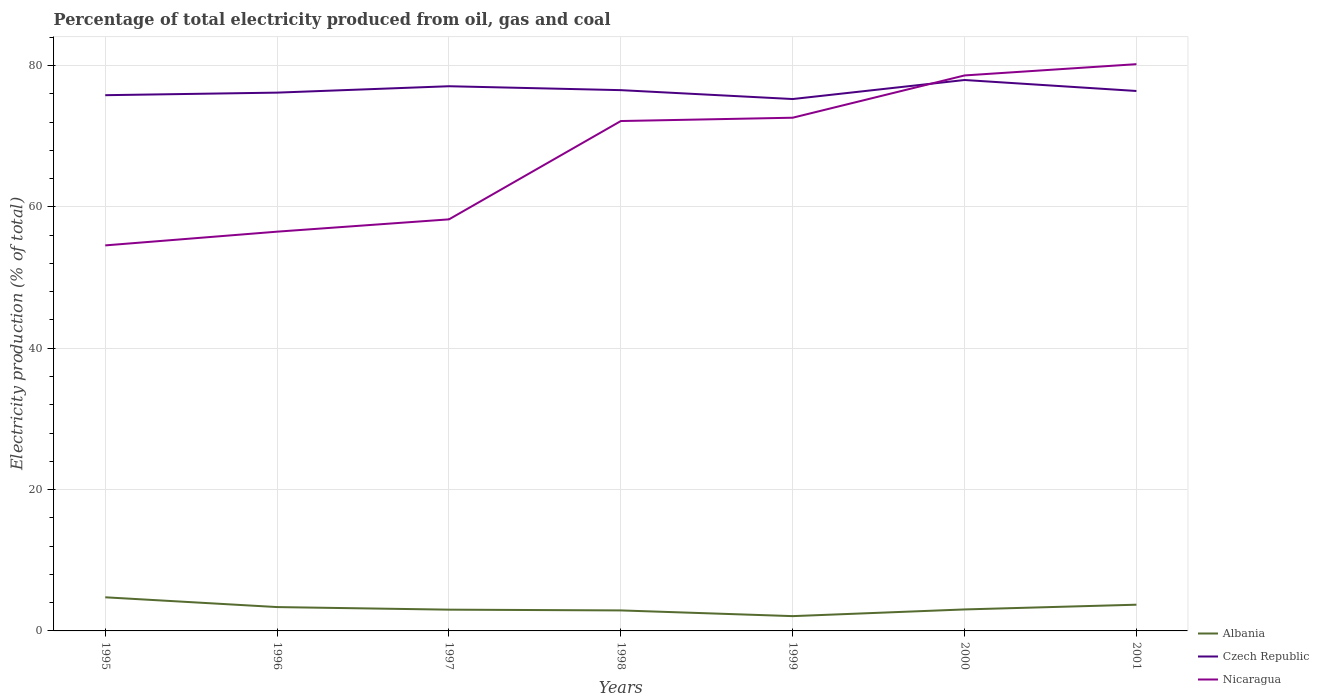Across all years, what is the maximum electricity production in in Nicaragua?
Your response must be concise. 54.56. What is the total electricity production in in Czech Republic in the graph?
Keep it short and to the point. 1.26. What is the difference between the highest and the second highest electricity production in in Nicaragua?
Provide a succinct answer. 25.64. What is the difference between the highest and the lowest electricity production in in Nicaragua?
Give a very brief answer. 4. How many lines are there?
Offer a very short reply. 3. How many years are there in the graph?
Your answer should be compact. 7. Are the values on the major ticks of Y-axis written in scientific E-notation?
Make the answer very short. No. Does the graph contain any zero values?
Make the answer very short. No. Does the graph contain grids?
Provide a succinct answer. Yes. What is the title of the graph?
Provide a succinct answer. Percentage of total electricity produced from oil, gas and coal. Does "Trinidad and Tobago" appear as one of the legend labels in the graph?
Your response must be concise. No. What is the label or title of the Y-axis?
Keep it short and to the point. Electricity production (% of total). What is the Electricity production (% of total) of Albania in 1995?
Your response must be concise. 4.76. What is the Electricity production (% of total) of Czech Republic in 1995?
Offer a very short reply. 75.81. What is the Electricity production (% of total) in Nicaragua in 1995?
Ensure brevity in your answer.  54.56. What is the Electricity production (% of total) of Albania in 1996?
Keep it short and to the point. 3.37. What is the Electricity production (% of total) in Czech Republic in 1996?
Provide a short and direct response. 76.17. What is the Electricity production (% of total) in Nicaragua in 1996?
Your answer should be compact. 56.5. What is the Electricity production (% of total) of Albania in 1997?
Offer a terse response. 3.01. What is the Electricity production (% of total) of Czech Republic in 1997?
Your response must be concise. 77.08. What is the Electricity production (% of total) of Nicaragua in 1997?
Provide a succinct answer. 58.24. What is the Electricity production (% of total) in Albania in 1998?
Give a very brief answer. 2.9. What is the Electricity production (% of total) in Czech Republic in 1998?
Provide a short and direct response. 76.52. What is the Electricity production (% of total) in Nicaragua in 1998?
Your answer should be very brief. 72.15. What is the Electricity production (% of total) in Albania in 1999?
Provide a short and direct response. 2.09. What is the Electricity production (% of total) in Czech Republic in 1999?
Ensure brevity in your answer.  75.26. What is the Electricity production (% of total) in Nicaragua in 1999?
Make the answer very short. 72.62. What is the Electricity production (% of total) in Albania in 2000?
Your answer should be very brief. 3.04. What is the Electricity production (% of total) of Czech Republic in 2000?
Your answer should be compact. 77.96. What is the Electricity production (% of total) in Nicaragua in 2000?
Your answer should be very brief. 78.6. What is the Electricity production (% of total) of Albania in 2001?
Offer a very short reply. 3.71. What is the Electricity production (% of total) of Czech Republic in 2001?
Your answer should be compact. 76.4. What is the Electricity production (% of total) of Nicaragua in 2001?
Your answer should be compact. 80.2. Across all years, what is the maximum Electricity production (% of total) of Albania?
Make the answer very short. 4.76. Across all years, what is the maximum Electricity production (% of total) of Czech Republic?
Offer a terse response. 77.96. Across all years, what is the maximum Electricity production (% of total) of Nicaragua?
Your response must be concise. 80.2. Across all years, what is the minimum Electricity production (% of total) of Albania?
Offer a very short reply. 2.09. Across all years, what is the minimum Electricity production (% of total) in Czech Republic?
Make the answer very short. 75.26. Across all years, what is the minimum Electricity production (% of total) in Nicaragua?
Your answer should be very brief. 54.56. What is the total Electricity production (% of total) of Albania in the graph?
Your answer should be very brief. 22.89. What is the total Electricity production (% of total) of Czech Republic in the graph?
Offer a very short reply. 535.21. What is the total Electricity production (% of total) of Nicaragua in the graph?
Provide a short and direct response. 472.87. What is the difference between the Electricity production (% of total) in Albania in 1995 and that in 1996?
Provide a short and direct response. 1.38. What is the difference between the Electricity production (% of total) of Czech Republic in 1995 and that in 1996?
Give a very brief answer. -0.36. What is the difference between the Electricity production (% of total) in Nicaragua in 1995 and that in 1996?
Make the answer very short. -1.94. What is the difference between the Electricity production (% of total) in Albania in 1995 and that in 1997?
Make the answer very short. 1.75. What is the difference between the Electricity production (% of total) of Czech Republic in 1995 and that in 1997?
Provide a succinct answer. -1.27. What is the difference between the Electricity production (% of total) of Nicaragua in 1995 and that in 1997?
Make the answer very short. -3.68. What is the difference between the Electricity production (% of total) in Albania in 1995 and that in 1998?
Offer a terse response. 1.86. What is the difference between the Electricity production (% of total) of Czech Republic in 1995 and that in 1998?
Keep it short and to the point. -0.71. What is the difference between the Electricity production (% of total) in Nicaragua in 1995 and that in 1998?
Give a very brief answer. -17.6. What is the difference between the Electricity production (% of total) in Albania in 1995 and that in 1999?
Your answer should be very brief. 2.66. What is the difference between the Electricity production (% of total) in Czech Republic in 1995 and that in 1999?
Keep it short and to the point. 0.55. What is the difference between the Electricity production (% of total) in Nicaragua in 1995 and that in 1999?
Keep it short and to the point. -18.07. What is the difference between the Electricity production (% of total) of Albania in 1995 and that in 2000?
Your response must be concise. 1.72. What is the difference between the Electricity production (% of total) of Czech Republic in 1995 and that in 2000?
Give a very brief answer. -2.15. What is the difference between the Electricity production (% of total) in Nicaragua in 1995 and that in 2000?
Give a very brief answer. -24.05. What is the difference between the Electricity production (% of total) of Albania in 1995 and that in 2001?
Provide a succinct answer. 1.05. What is the difference between the Electricity production (% of total) in Czech Republic in 1995 and that in 2001?
Make the answer very short. -0.59. What is the difference between the Electricity production (% of total) in Nicaragua in 1995 and that in 2001?
Offer a terse response. -25.64. What is the difference between the Electricity production (% of total) in Albania in 1996 and that in 1997?
Make the answer very short. 0.37. What is the difference between the Electricity production (% of total) in Czech Republic in 1996 and that in 1997?
Provide a succinct answer. -0.9. What is the difference between the Electricity production (% of total) of Nicaragua in 1996 and that in 1997?
Your answer should be very brief. -1.74. What is the difference between the Electricity production (% of total) of Albania in 1996 and that in 1998?
Keep it short and to the point. 0.47. What is the difference between the Electricity production (% of total) in Czech Republic in 1996 and that in 1998?
Offer a terse response. -0.35. What is the difference between the Electricity production (% of total) in Nicaragua in 1996 and that in 1998?
Your answer should be compact. -15.66. What is the difference between the Electricity production (% of total) in Albania in 1996 and that in 1999?
Provide a succinct answer. 1.28. What is the difference between the Electricity production (% of total) of Czech Republic in 1996 and that in 1999?
Make the answer very short. 0.91. What is the difference between the Electricity production (% of total) of Nicaragua in 1996 and that in 1999?
Offer a terse response. -16.12. What is the difference between the Electricity production (% of total) in Albania in 1996 and that in 2000?
Offer a terse response. 0.34. What is the difference between the Electricity production (% of total) of Czech Republic in 1996 and that in 2000?
Ensure brevity in your answer.  -1.78. What is the difference between the Electricity production (% of total) in Nicaragua in 1996 and that in 2000?
Provide a succinct answer. -22.11. What is the difference between the Electricity production (% of total) of Albania in 1996 and that in 2001?
Ensure brevity in your answer.  -0.34. What is the difference between the Electricity production (% of total) of Czech Republic in 1996 and that in 2001?
Your answer should be compact. -0.23. What is the difference between the Electricity production (% of total) of Nicaragua in 1996 and that in 2001?
Give a very brief answer. -23.7. What is the difference between the Electricity production (% of total) in Albania in 1997 and that in 1998?
Keep it short and to the point. 0.11. What is the difference between the Electricity production (% of total) of Czech Republic in 1997 and that in 1998?
Provide a succinct answer. 0.55. What is the difference between the Electricity production (% of total) of Nicaragua in 1997 and that in 1998?
Make the answer very short. -13.91. What is the difference between the Electricity production (% of total) of Albania in 1997 and that in 1999?
Offer a terse response. 0.92. What is the difference between the Electricity production (% of total) of Czech Republic in 1997 and that in 1999?
Keep it short and to the point. 1.81. What is the difference between the Electricity production (% of total) of Nicaragua in 1997 and that in 1999?
Ensure brevity in your answer.  -14.38. What is the difference between the Electricity production (% of total) in Albania in 1997 and that in 2000?
Keep it short and to the point. -0.03. What is the difference between the Electricity production (% of total) in Czech Republic in 1997 and that in 2000?
Offer a terse response. -0.88. What is the difference between the Electricity production (% of total) in Nicaragua in 1997 and that in 2000?
Your answer should be compact. -20.37. What is the difference between the Electricity production (% of total) of Albania in 1997 and that in 2001?
Provide a succinct answer. -0.7. What is the difference between the Electricity production (% of total) in Czech Republic in 1997 and that in 2001?
Provide a succinct answer. 0.67. What is the difference between the Electricity production (% of total) of Nicaragua in 1997 and that in 2001?
Your response must be concise. -21.96. What is the difference between the Electricity production (% of total) of Albania in 1998 and that in 1999?
Provide a succinct answer. 0.81. What is the difference between the Electricity production (% of total) in Czech Republic in 1998 and that in 1999?
Ensure brevity in your answer.  1.26. What is the difference between the Electricity production (% of total) of Nicaragua in 1998 and that in 1999?
Your response must be concise. -0.47. What is the difference between the Electricity production (% of total) in Albania in 1998 and that in 2000?
Offer a terse response. -0.14. What is the difference between the Electricity production (% of total) in Czech Republic in 1998 and that in 2000?
Your response must be concise. -1.44. What is the difference between the Electricity production (% of total) in Nicaragua in 1998 and that in 2000?
Provide a short and direct response. -6.45. What is the difference between the Electricity production (% of total) of Albania in 1998 and that in 2001?
Your answer should be very brief. -0.81. What is the difference between the Electricity production (% of total) of Czech Republic in 1998 and that in 2001?
Offer a very short reply. 0.12. What is the difference between the Electricity production (% of total) in Nicaragua in 1998 and that in 2001?
Offer a terse response. -8.04. What is the difference between the Electricity production (% of total) in Albania in 1999 and that in 2000?
Your answer should be compact. -0.95. What is the difference between the Electricity production (% of total) of Czech Republic in 1999 and that in 2000?
Your answer should be very brief. -2.69. What is the difference between the Electricity production (% of total) of Nicaragua in 1999 and that in 2000?
Provide a succinct answer. -5.98. What is the difference between the Electricity production (% of total) of Albania in 1999 and that in 2001?
Give a very brief answer. -1.62. What is the difference between the Electricity production (% of total) of Czech Republic in 1999 and that in 2001?
Offer a terse response. -1.14. What is the difference between the Electricity production (% of total) of Nicaragua in 1999 and that in 2001?
Offer a very short reply. -7.58. What is the difference between the Electricity production (% of total) in Albania in 2000 and that in 2001?
Your answer should be compact. -0.67. What is the difference between the Electricity production (% of total) in Czech Republic in 2000 and that in 2001?
Provide a short and direct response. 1.55. What is the difference between the Electricity production (% of total) of Nicaragua in 2000 and that in 2001?
Give a very brief answer. -1.59. What is the difference between the Electricity production (% of total) of Albania in 1995 and the Electricity production (% of total) of Czech Republic in 1996?
Keep it short and to the point. -71.42. What is the difference between the Electricity production (% of total) of Albania in 1995 and the Electricity production (% of total) of Nicaragua in 1996?
Provide a short and direct response. -51.74. What is the difference between the Electricity production (% of total) of Czech Republic in 1995 and the Electricity production (% of total) of Nicaragua in 1996?
Your answer should be very brief. 19.31. What is the difference between the Electricity production (% of total) in Albania in 1995 and the Electricity production (% of total) in Czech Republic in 1997?
Keep it short and to the point. -72.32. What is the difference between the Electricity production (% of total) in Albania in 1995 and the Electricity production (% of total) in Nicaragua in 1997?
Ensure brevity in your answer.  -53.48. What is the difference between the Electricity production (% of total) in Czech Republic in 1995 and the Electricity production (% of total) in Nicaragua in 1997?
Your answer should be compact. 17.57. What is the difference between the Electricity production (% of total) in Albania in 1995 and the Electricity production (% of total) in Czech Republic in 1998?
Ensure brevity in your answer.  -71.77. What is the difference between the Electricity production (% of total) in Albania in 1995 and the Electricity production (% of total) in Nicaragua in 1998?
Give a very brief answer. -67.4. What is the difference between the Electricity production (% of total) in Czech Republic in 1995 and the Electricity production (% of total) in Nicaragua in 1998?
Your answer should be compact. 3.66. What is the difference between the Electricity production (% of total) of Albania in 1995 and the Electricity production (% of total) of Czech Republic in 1999?
Make the answer very short. -70.51. What is the difference between the Electricity production (% of total) of Albania in 1995 and the Electricity production (% of total) of Nicaragua in 1999?
Your answer should be very brief. -67.86. What is the difference between the Electricity production (% of total) in Czech Republic in 1995 and the Electricity production (% of total) in Nicaragua in 1999?
Your response must be concise. 3.19. What is the difference between the Electricity production (% of total) of Albania in 1995 and the Electricity production (% of total) of Czech Republic in 2000?
Keep it short and to the point. -73.2. What is the difference between the Electricity production (% of total) in Albania in 1995 and the Electricity production (% of total) in Nicaragua in 2000?
Your response must be concise. -73.85. What is the difference between the Electricity production (% of total) in Czech Republic in 1995 and the Electricity production (% of total) in Nicaragua in 2000?
Your response must be concise. -2.79. What is the difference between the Electricity production (% of total) of Albania in 1995 and the Electricity production (% of total) of Czech Republic in 2001?
Your answer should be very brief. -71.65. What is the difference between the Electricity production (% of total) in Albania in 1995 and the Electricity production (% of total) in Nicaragua in 2001?
Ensure brevity in your answer.  -75.44. What is the difference between the Electricity production (% of total) of Czech Republic in 1995 and the Electricity production (% of total) of Nicaragua in 2001?
Make the answer very short. -4.39. What is the difference between the Electricity production (% of total) of Albania in 1996 and the Electricity production (% of total) of Czech Republic in 1997?
Provide a succinct answer. -73.7. What is the difference between the Electricity production (% of total) of Albania in 1996 and the Electricity production (% of total) of Nicaragua in 1997?
Your answer should be very brief. -54.86. What is the difference between the Electricity production (% of total) in Czech Republic in 1996 and the Electricity production (% of total) in Nicaragua in 1997?
Offer a terse response. 17.93. What is the difference between the Electricity production (% of total) in Albania in 1996 and the Electricity production (% of total) in Czech Republic in 1998?
Ensure brevity in your answer.  -73.15. What is the difference between the Electricity production (% of total) in Albania in 1996 and the Electricity production (% of total) in Nicaragua in 1998?
Keep it short and to the point. -68.78. What is the difference between the Electricity production (% of total) of Czech Republic in 1996 and the Electricity production (% of total) of Nicaragua in 1998?
Offer a terse response. 4.02. What is the difference between the Electricity production (% of total) in Albania in 1996 and the Electricity production (% of total) in Czech Republic in 1999?
Your response must be concise. -71.89. What is the difference between the Electricity production (% of total) of Albania in 1996 and the Electricity production (% of total) of Nicaragua in 1999?
Your response must be concise. -69.25. What is the difference between the Electricity production (% of total) of Czech Republic in 1996 and the Electricity production (% of total) of Nicaragua in 1999?
Give a very brief answer. 3.55. What is the difference between the Electricity production (% of total) in Albania in 1996 and the Electricity production (% of total) in Czech Republic in 2000?
Offer a very short reply. -74.58. What is the difference between the Electricity production (% of total) in Albania in 1996 and the Electricity production (% of total) in Nicaragua in 2000?
Provide a short and direct response. -75.23. What is the difference between the Electricity production (% of total) in Czech Republic in 1996 and the Electricity production (% of total) in Nicaragua in 2000?
Offer a very short reply. -2.43. What is the difference between the Electricity production (% of total) in Albania in 1996 and the Electricity production (% of total) in Czech Republic in 2001?
Make the answer very short. -73.03. What is the difference between the Electricity production (% of total) of Albania in 1996 and the Electricity production (% of total) of Nicaragua in 2001?
Ensure brevity in your answer.  -76.82. What is the difference between the Electricity production (% of total) of Czech Republic in 1996 and the Electricity production (% of total) of Nicaragua in 2001?
Make the answer very short. -4.03. What is the difference between the Electricity production (% of total) of Albania in 1997 and the Electricity production (% of total) of Czech Republic in 1998?
Offer a very short reply. -73.51. What is the difference between the Electricity production (% of total) in Albania in 1997 and the Electricity production (% of total) in Nicaragua in 1998?
Make the answer very short. -69.14. What is the difference between the Electricity production (% of total) of Czech Republic in 1997 and the Electricity production (% of total) of Nicaragua in 1998?
Give a very brief answer. 4.92. What is the difference between the Electricity production (% of total) of Albania in 1997 and the Electricity production (% of total) of Czech Republic in 1999?
Offer a terse response. -72.26. What is the difference between the Electricity production (% of total) of Albania in 1997 and the Electricity production (% of total) of Nicaragua in 1999?
Provide a short and direct response. -69.61. What is the difference between the Electricity production (% of total) of Czech Republic in 1997 and the Electricity production (% of total) of Nicaragua in 1999?
Ensure brevity in your answer.  4.45. What is the difference between the Electricity production (% of total) of Albania in 1997 and the Electricity production (% of total) of Czech Republic in 2000?
Ensure brevity in your answer.  -74.95. What is the difference between the Electricity production (% of total) in Albania in 1997 and the Electricity production (% of total) in Nicaragua in 2000?
Your response must be concise. -75.6. What is the difference between the Electricity production (% of total) in Czech Republic in 1997 and the Electricity production (% of total) in Nicaragua in 2000?
Provide a succinct answer. -1.53. What is the difference between the Electricity production (% of total) in Albania in 1997 and the Electricity production (% of total) in Czech Republic in 2001?
Provide a short and direct response. -73.4. What is the difference between the Electricity production (% of total) of Albania in 1997 and the Electricity production (% of total) of Nicaragua in 2001?
Your answer should be compact. -77.19. What is the difference between the Electricity production (% of total) of Czech Republic in 1997 and the Electricity production (% of total) of Nicaragua in 2001?
Offer a terse response. -3.12. What is the difference between the Electricity production (% of total) in Albania in 1998 and the Electricity production (% of total) in Czech Republic in 1999?
Make the answer very short. -72.36. What is the difference between the Electricity production (% of total) in Albania in 1998 and the Electricity production (% of total) in Nicaragua in 1999?
Your answer should be very brief. -69.72. What is the difference between the Electricity production (% of total) of Czech Republic in 1998 and the Electricity production (% of total) of Nicaragua in 1999?
Provide a short and direct response. 3.9. What is the difference between the Electricity production (% of total) in Albania in 1998 and the Electricity production (% of total) in Czech Republic in 2000?
Give a very brief answer. -75.06. What is the difference between the Electricity production (% of total) in Albania in 1998 and the Electricity production (% of total) in Nicaragua in 2000?
Your answer should be very brief. -75.7. What is the difference between the Electricity production (% of total) in Czech Republic in 1998 and the Electricity production (% of total) in Nicaragua in 2000?
Your answer should be very brief. -2.08. What is the difference between the Electricity production (% of total) of Albania in 1998 and the Electricity production (% of total) of Czech Republic in 2001?
Provide a succinct answer. -73.5. What is the difference between the Electricity production (% of total) in Albania in 1998 and the Electricity production (% of total) in Nicaragua in 2001?
Provide a short and direct response. -77.3. What is the difference between the Electricity production (% of total) of Czech Republic in 1998 and the Electricity production (% of total) of Nicaragua in 2001?
Make the answer very short. -3.68. What is the difference between the Electricity production (% of total) in Albania in 1999 and the Electricity production (% of total) in Czech Republic in 2000?
Offer a very short reply. -75.86. What is the difference between the Electricity production (% of total) of Albania in 1999 and the Electricity production (% of total) of Nicaragua in 2000?
Your response must be concise. -76.51. What is the difference between the Electricity production (% of total) of Czech Republic in 1999 and the Electricity production (% of total) of Nicaragua in 2000?
Your answer should be compact. -3.34. What is the difference between the Electricity production (% of total) in Albania in 1999 and the Electricity production (% of total) in Czech Republic in 2001?
Keep it short and to the point. -74.31. What is the difference between the Electricity production (% of total) of Albania in 1999 and the Electricity production (% of total) of Nicaragua in 2001?
Offer a very short reply. -78.1. What is the difference between the Electricity production (% of total) of Czech Republic in 1999 and the Electricity production (% of total) of Nicaragua in 2001?
Ensure brevity in your answer.  -4.93. What is the difference between the Electricity production (% of total) of Albania in 2000 and the Electricity production (% of total) of Czech Republic in 2001?
Your answer should be compact. -73.37. What is the difference between the Electricity production (% of total) in Albania in 2000 and the Electricity production (% of total) in Nicaragua in 2001?
Provide a succinct answer. -77.16. What is the difference between the Electricity production (% of total) of Czech Republic in 2000 and the Electricity production (% of total) of Nicaragua in 2001?
Your answer should be very brief. -2.24. What is the average Electricity production (% of total) of Albania per year?
Give a very brief answer. 3.27. What is the average Electricity production (% of total) in Czech Republic per year?
Your response must be concise. 76.46. What is the average Electricity production (% of total) of Nicaragua per year?
Keep it short and to the point. 67.55. In the year 1995, what is the difference between the Electricity production (% of total) of Albania and Electricity production (% of total) of Czech Republic?
Offer a very short reply. -71.05. In the year 1995, what is the difference between the Electricity production (% of total) in Albania and Electricity production (% of total) in Nicaragua?
Your answer should be very brief. -49.8. In the year 1995, what is the difference between the Electricity production (% of total) of Czech Republic and Electricity production (% of total) of Nicaragua?
Your response must be concise. 21.25. In the year 1996, what is the difference between the Electricity production (% of total) of Albania and Electricity production (% of total) of Czech Republic?
Ensure brevity in your answer.  -72.8. In the year 1996, what is the difference between the Electricity production (% of total) of Albania and Electricity production (% of total) of Nicaragua?
Ensure brevity in your answer.  -53.12. In the year 1996, what is the difference between the Electricity production (% of total) in Czech Republic and Electricity production (% of total) in Nicaragua?
Offer a terse response. 19.68. In the year 1997, what is the difference between the Electricity production (% of total) in Albania and Electricity production (% of total) in Czech Republic?
Ensure brevity in your answer.  -74.07. In the year 1997, what is the difference between the Electricity production (% of total) of Albania and Electricity production (% of total) of Nicaragua?
Keep it short and to the point. -55.23. In the year 1997, what is the difference between the Electricity production (% of total) of Czech Republic and Electricity production (% of total) of Nicaragua?
Provide a short and direct response. 18.84. In the year 1998, what is the difference between the Electricity production (% of total) in Albania and Electricity production (% of total) in Czech Republic?
Provide a short and direct response. -73.62. In the year 1998, what is the difference between the Electricity production (% of total) in Albania and Electricity production (% of total) in Nicaragua?
Ensure brevity in your answer.  -69.25. In the year 1998, what is the difference between the Electricity production (% of total) in Czech Republic and Electricity production (% of total) in Nicaragua?
Your answer should be compact. 4.37. In the year 1999, what is the difference between the Electricity production (% of total) in Albania and Electricity production (% of total) in Czech Republic?
Keep it short and to the point. -73.17. In the year 1999, what is the difference between the Electricity production (% of total) of Albania and Electricity production (% of total) of Nicaragua?
Give a very brief answer. -70.53. In the year 1999, what is the difference between the Electricity production (% of total) in Czech Republic and Electricity production (% of total) in Nicaragua?
Your answer should be very brief. 2.64. In the year 2000, what is the difference between the Electricity production (% of total) of Albania and Electricity production (% of total) of Czech Republic?
Offer a very short reply. -74.92. In the year 2000, what is the difference between the Electricity production (% of total) in Albania and Electricity production (% of total) in Nicaragua?
Your answer should be compact. -75.57. In the year 2000, what is the difference between the Electricity production (% of total) of Czech Republic and Electricity production (% of total) of Nicaragua?
Keep it short and to the point. -0.65. In the year 2001, what is the difference between the Electricity production (% of total) in Albania and Electricity production (% of total) in Czech Republic?
Your answer should be compact. -72.69. In the year 2001, what is the difference between the Electricity production (% of total) of Albania and Electricity production (% of total) of Nicaragua?
Provide a short and direct response. -76.49. In the year 2001, what is the difference between the Electricity production (% of total) of Czech Republic and Electricity production (% of total) of Nicaragua?
Your response must be concise. -3.79. What is the ratio of the Electricity production (% of total) in Albania in 1995 to that in 1996?
Offer a very short reply. 1.41. What is the ratio of the Electricity production (% of total) of Nicaragua in 1995 to that in 1996?
Your answer should be very brief. 0.97. What is the ratio of the Electricity production (% of total) in Albania in 1995 to that in 1997?
Offer a very short reply. 1.58. What is the ratio of the Electricity production (% of total) of Czech Republic in 1995 to that in 1997?
Give a very brief answer. 0.98. What is the ratio of the Electricity production (% of total) of Nicaragua in 1995 to that in 1997?
Give a very brief answer. 0.94. What is the ratio of the Electricity production (% of total) of Albania in 1995 to that in 1998?
Provide a succinct answer. 1.64. What is the ratio of the Electricity production (% of total) of Czech Republic in 1995 to that in 1998?
Keep it short and to the point. 0.99. What is the ratio of the Electricity production (% of total) of Nicaragua in 1995 to that in 1998?
Ensure brevity in your answer.  0.76. What is the ratio of the Electricity production (% of total) of Albania in 1995 to that in 1999?
Provide a short and direct response. 2.27. What is the ratio of the Electricity production (% of total) in Nicaragua in 1995 to that in 1999?
Provide a succinct answer. 0.75. What is the ratio of the Electricity production (% of total) in Albania in 1995 to that in 2000?
Ensure brevity in your answer.  1.57. What is the ratio of the Electricity production (% of total) in Czech Republic in 1995 to that in 2000?
Your response must be concise. 0.97. What is the ratio of the Electricity production (% of total) of Nicaragua in 1995 to that in 2000?
Your answer should be compact. 0.69. What is the ratio of the Electricity production (% of total) of Albania in 1995 to that in 2001?
Keep it short and to the point. 1.28. What is the ratio of the Electricity production (% of total) in Nicaragua in 1995 to that in 2001?
Keep it short and to the point. 0.68. What is the ratio of the Electricity production (% of total) in Albania in 1996 to that in 1997?
Your response must be concise. 1.12. What is the ratio of the Electricity production (% of total) in Czech Republic in 1996 to that in 1997?
Give a very brief answer. 0.99. What is the ratio of the Electricity production (% of total) of Nicaragua in 1996 to that in 1997?
Give a very brief answer. 0.97. What is the ratio of the Electricity production (% of total) in Albania in 1996 to that in 1998?
Your answer should be very brief. 1.16. What is the ratio of the Electricity production (% of total) of Czech Republic in 1996 to that in 1998?
Provide a short and direct response. 1. What is the ratio of the Electricity production (% of total) in Nicaragua in 1996 to that in 1998?
Give a very brief answer. 0.78. What is the ratio of the Electricity production (% of total) in Albania in 1996 to that in 1999?
Your answer should be compact. 1.61. What is the ratio of the Electricity production (% of total) of Czech Republic in 1996 to that in 1999?
Keep it short and to the point. 1.01. What is the ratio of the Electricity production (% of total) in Nicaragua in 1996 to that in 1999?
Provide a short and direct response. 0.78. What is the ratio of the Electricity production (% of total) in Albania in 1996 to that in 2000?
Keep it short and to the point. 1.11. What is the ratio of the Electricity production (% of total) in Czech Republic in 1996 to that in 2000?
Provide a succinct answer. 0.98. What is the ratio of the Electricity production (% of total) in Nicaragua in 1996 to that in 2000?
Make the answer very short. 0.72. What is the ratio of the Electricity production (% of total) in Albania in 1996 to that in 2001?
Provide a short and direct response. 0.91. What is the ratio of the Electricity production (% of total) of Nicaragua in 1996 to that in 2001?
Offer a very short reply. 0.7. What is the ratio of the Electricity production (% of total) of Albania in 1997 to that in 1998?
Ensure brevity in your answer.  1.04. What is the ratio of the Electricity production (% of total) in Czech Republic in 1997 to that in 1998?
Your answer should be compact. 1.01. What is the ratio of the Electricity production (% of total) in Nicaragua in 1997 to that in 1998?
Offer a terse response. 0.81. What is the ratio of the Electricity production (% of total) in Albania in 1997 to that in 1999?
Keep it short and to the point. 1.44. What is the ratio of the Electricity production (% of total) in Czech Republic in 1997 to that in 1999?
Your response must be concise. 1.02. What is the ratio of the Electricity production (% of total) of Nicaragua in 1997 to that in 1999?
Your response must be concise. 0.8. What is the ratio of the Electricity production (% of total) in Albania in 1997 to that in 2000?
Offer a terse response. 0.99. What is the ratio of the Electricity production (% of total) of Czech Republic in 1997 to that in 2000?
Ensure brevity in your answer.  0.99. What is the ratio of the Electricity production (% of total) of Nicaragua in 1997 to that in 2000?
Ensure brevity in your answer.  0.74. What is the ratio of the Electricity production (% of total) of Albania in 1997 to that in 2001?
Offer a very short reply. 0.81. What is the ratio of the Electricity production (% of total) in Czech Republic in 1997 to that in 2001?
Your answer should be very brief. 1.01. What is the ratio of the Electricity production (% of total) of Nicaragua in 1997 to that in 2001?
Ensure brevity in your answer.  0.73. What is the ratio of the Electricity production (% of total) in Albania in 1998 to that in 1999?
Make the answer very short. 1.39. What is the ratio of the Electricity production (% of total) of Czech Republic in 1998 to that in 1999?
Your response must be concise. 1.02. What is the ratio of the Electricity production (% of total) in Albania in 1998 to that in 2000?
Make the answer very short. 0.95. What is the ratio of the Electricity production (% of total) of Czech Republic in 1998 to that in 2000?
Offer a very short reply. 0.98. What is the ratio of the Electricity production (% of total) of Nicaragua in 1998 to that in 2000?
Keep it short and to the point. 0.92. What is the ratio of the Electricity production (% of total) in Albania in 1998 to that in 2001?
Make the answer very short. 0.78. What is the ratio of the Electricity production (% of total) in Nicaragua in 1998 to that in 2001?
Your answer should be compact. 0.9. What is the ratio of the Electricity production (% of total) in Albania in 1999 to that in 2000?
Ensure brevity in your answer.  0.69. What is the ratio of the Electricity production (% of total) in Czech Republic in 1999 to that in 2000?
Your response must be concise. 0.97. What is the ratio of the Electricity production (% of total) in Nicaragua in 1999 to that in 2000?
Your answer should be very brief. 0.92. What is the ratio of the Electricity production (% of total) in Albania in 1999 to that in 2001?
Provide a succinct answer. 0.56. What is the ratio of the Electricity production (% of total) of Czech Republic in 1999 to that in 2001?
Offer a very short reply. 0.99. What is the ratio of the Electricity production (% of total) in Nicaragua in 1999 to that in 2001?
Provide a short and direct response. 0.91. What is the ratio of the Electricity production (% of total) of Albania in 2000 to that in 2001?
Offer a terse response. 0.82. What is the ratio of the Electricity production (% of total) of Czech Republic in 2000 to that in 2001?
Offer a terse response. 1.02. What is the ratio of the Electricity production (% of total) in Nicaragua in 2000 to that in 2001?
Your answer should be very brief. 0.98. What is the difference between the highest and the second highest Electricity production (% of total) of Albania?
Give a very brief answer. 1.05. What is the difference between the highest and the second highest Electricity production (% of total) of Czech Republic?
Provide a short and direct response. 0.88. What is the difference between the highest and the second highest Electricity production (% of total) of Nicaragua?
Make the answer very short. 1.59. What is the difference between the highest and the lowest Electricity production (% of total) in Albania?
Your response must be concise. 2.66. What is the difference between the highest and the lowest Electricity production (% of total) in Czech Republic?
Ensure brevity in your answer.  2.69. What is the difference between the highest and the lowest Electricity production (% of total) of Nicaragua?
Your answer should be compact. 25.64. 